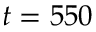<formula> <loc_0><loc_0><loc_500><loc_500>t = 5 5 0</formula> 